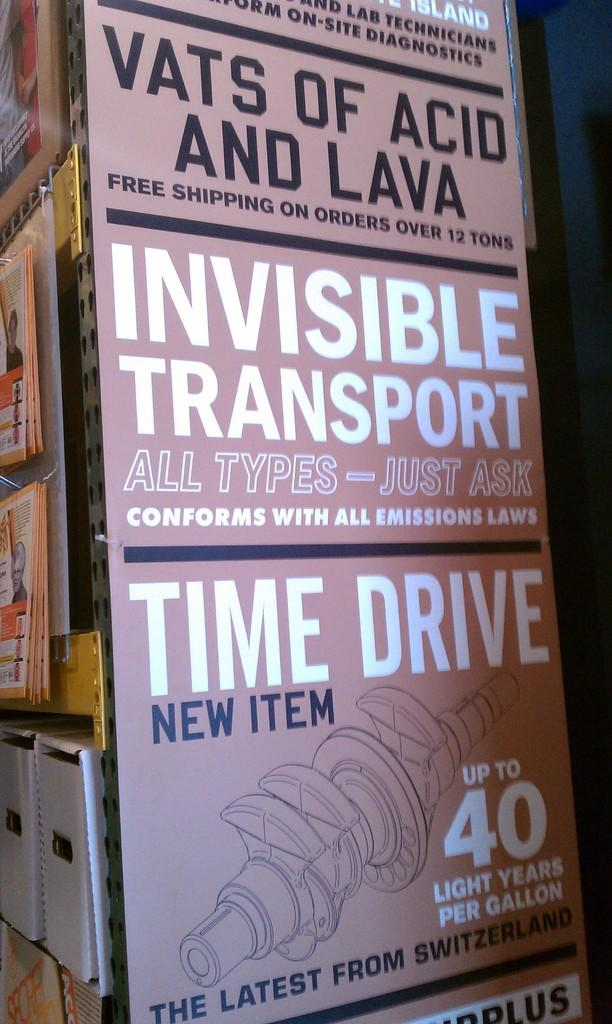<image>
Provide a brief description of the given image. The end store isle with an advertisement of Invisible Transport. 